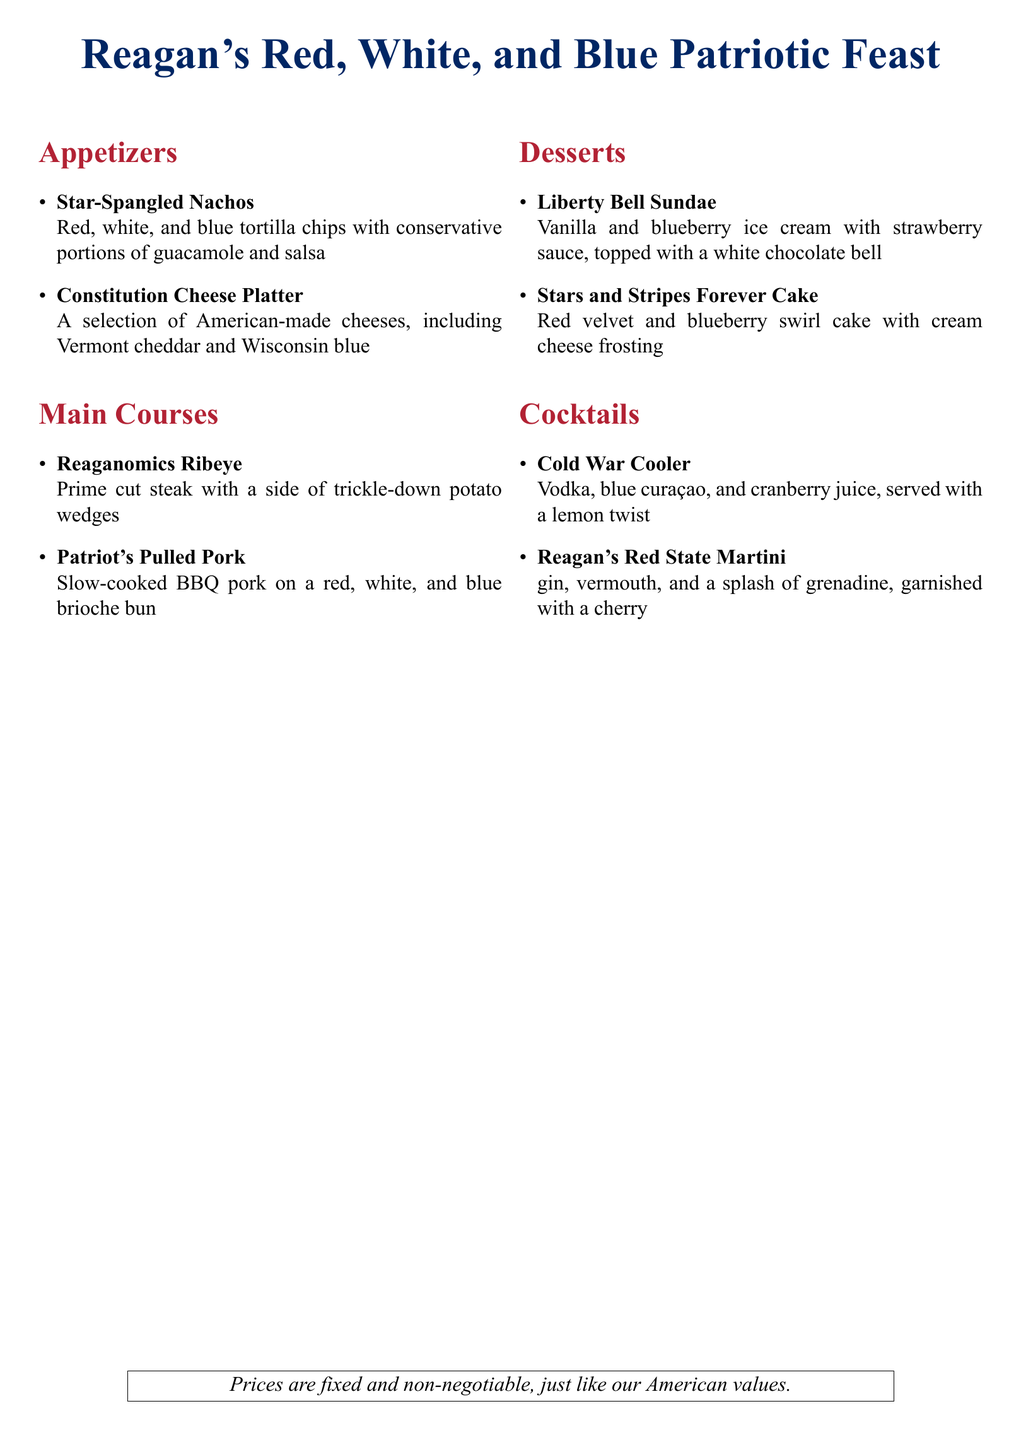What is the name of the dessert that features vanilla and blueberry ice cream? It is mentioned in the desserts section as the "Liberty Bell Sundae".
Answer: Liberty Bell Sundae How many appetizers are listed on the menu? The appetizers section lists two items: Star-Spangled Nachos and Constitution Cheese Platter.
Answer: 2 What type of steak is served in the main courses? The main courses feature a "Prime cut steak" called the "Reaganomics Ribeye".
Answer: Reaganomics Ribeye Which cocktail contains blue curaçao? The menu specifies that the "Cold War Cooler" cocktail includes blue curaçao.
Answer: Cold War Cooler What color is associated with the American-themed cocktails? The cocktails are labeled with the color red in the section header.
Answer: Red What is the garnish on the Reagan's Red State Martini? The drink is garnished with a cherry, as stated in the cocktails description.
Answer: Cherry What type of sauce tops the Liberty Bell Sundae? The dessert is topped with strawberry sauce, as indicated in the description.
Answer: Strawberry sauce Which two colors are prominently featured in the themed menu's title? The title specifically highlights red and blue in the "Reagan's Red, White, and Blue Patriotic Feast".
Answer: Red, blue What is meant by "fixed and non-negotiable" prices? This phrase indicates that prices are set and cannot be changed, reflecting strong American values mentioned in the note.
Answer: Fixed prices 